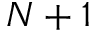Convert formula to latex. <formula><loc_0><loc_0><loc_500><loc_500>N + 1</formula> 